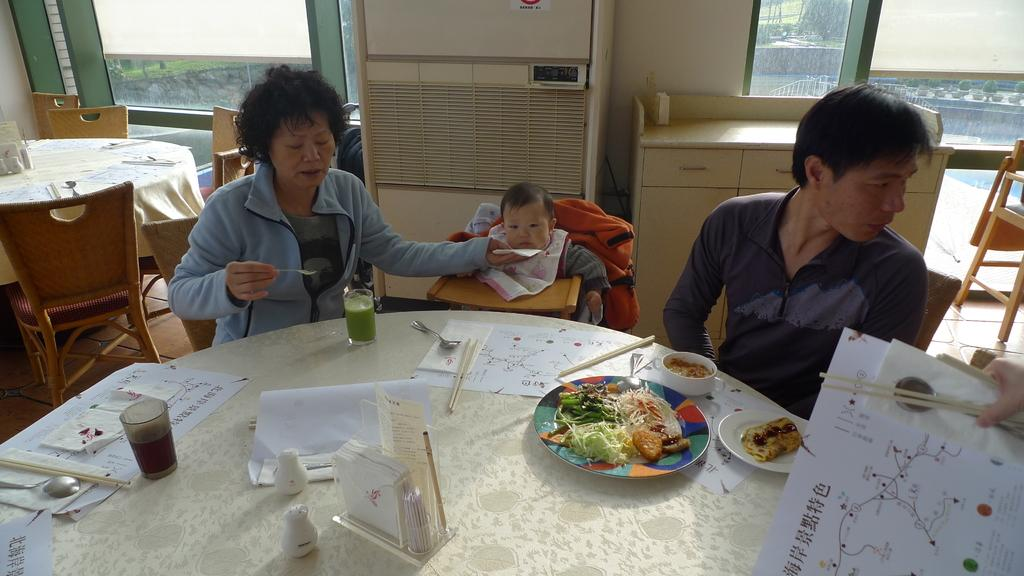Where was the image taken? The image was taken inside a house. What are the two people in the image doing? The two people are eating at a table. Can you describe the scene in the background? There is a small kid on a table in the background. What feature allows natural light to enter the room? There is a glass window in the image. What type of apparatus is being used by the pig in the image? There is no pig present in the image, and therefore no apparatus can be associated with it. 